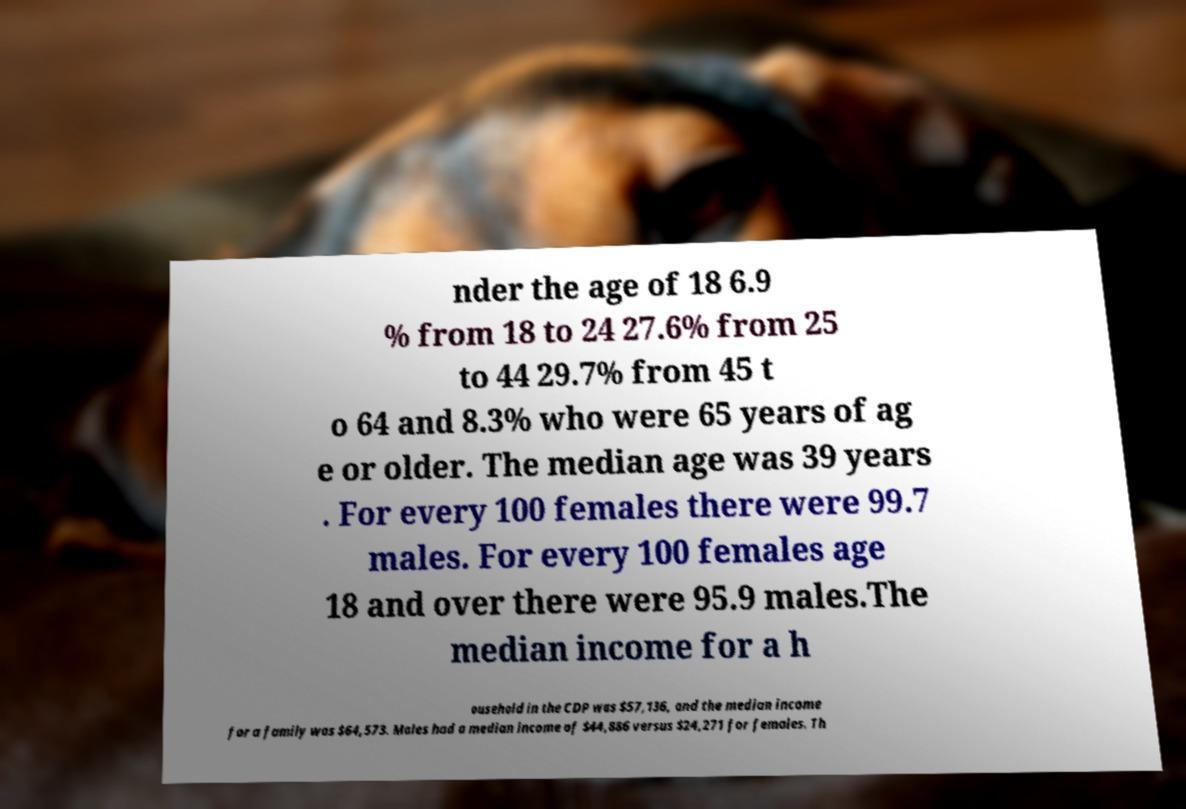I need the written content from this picture converted into text. Can you do that? nder the age of 18 6.9 % from 18 to 24 27.6% from 25 to 44 29.7% from 45 t o 64 and 8.3% who were 65 years of ag e or older. The median age was 39 years . For every 100 females there were 99.7 males. For every 100 females age 18 and over there were 95.9 males.The median income for a h ousehold in the CDP was $57,136, and the median income for a family was $64,573. Males had a median income of $44,886 versus $24,271 for females. Th 